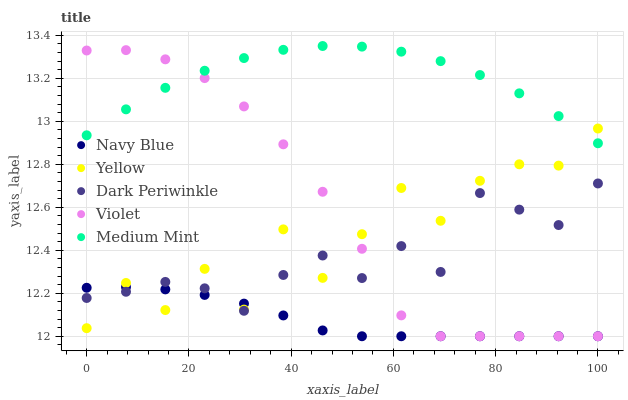Does Navy Blue have the minimum area under the curve?
Answer yes or no. Yes. Does Medium Mint have the maximum area under the curve?
Answer yes or no. Yes. Does Dark Periwinkle have the minimum area under the curve?
Answer yes or no. No. Does Dark Periwinkle have the maximum area under the curve?
Answer yes or no. No. Is Navy Blue the smoothest?
Answer yes or no. Yes. Is Yellow the roughest?
Answer yes or no. Yes. Is Dark Periwinkle the smoothest?
Answer yes or no. No. Is Dark Periwinkle the roughest?
Answer yes or no. No. Does Navy Blue have the lowest value?
Answer yes or no. Yes. Does Dark Periwinkle have the lowest value?
Answer yes or no. No. Does Medium Mint have the highest value?
Answer yes or no. Yes. Does Dark Periwinkle have the highest value?
Answer yes or no. No. Is Navy Blue less than Medium Mint?
Answer yes or no. Yes. Is Medium Mint greater than Dark Periwinkle?
Answer yes or no. Yes. Does Dark Periwinkle intersect Navy Blue?
Answer yes or no. Yes. Is Dark Periwinkle less than Navy Blue?
Answer yes or no. No. Is Dark Periwinkle greater than Navy Blue?
Answer yes or no. No. Does Navy Blue intersect Medium Mint?
Answer yes or no. No. 